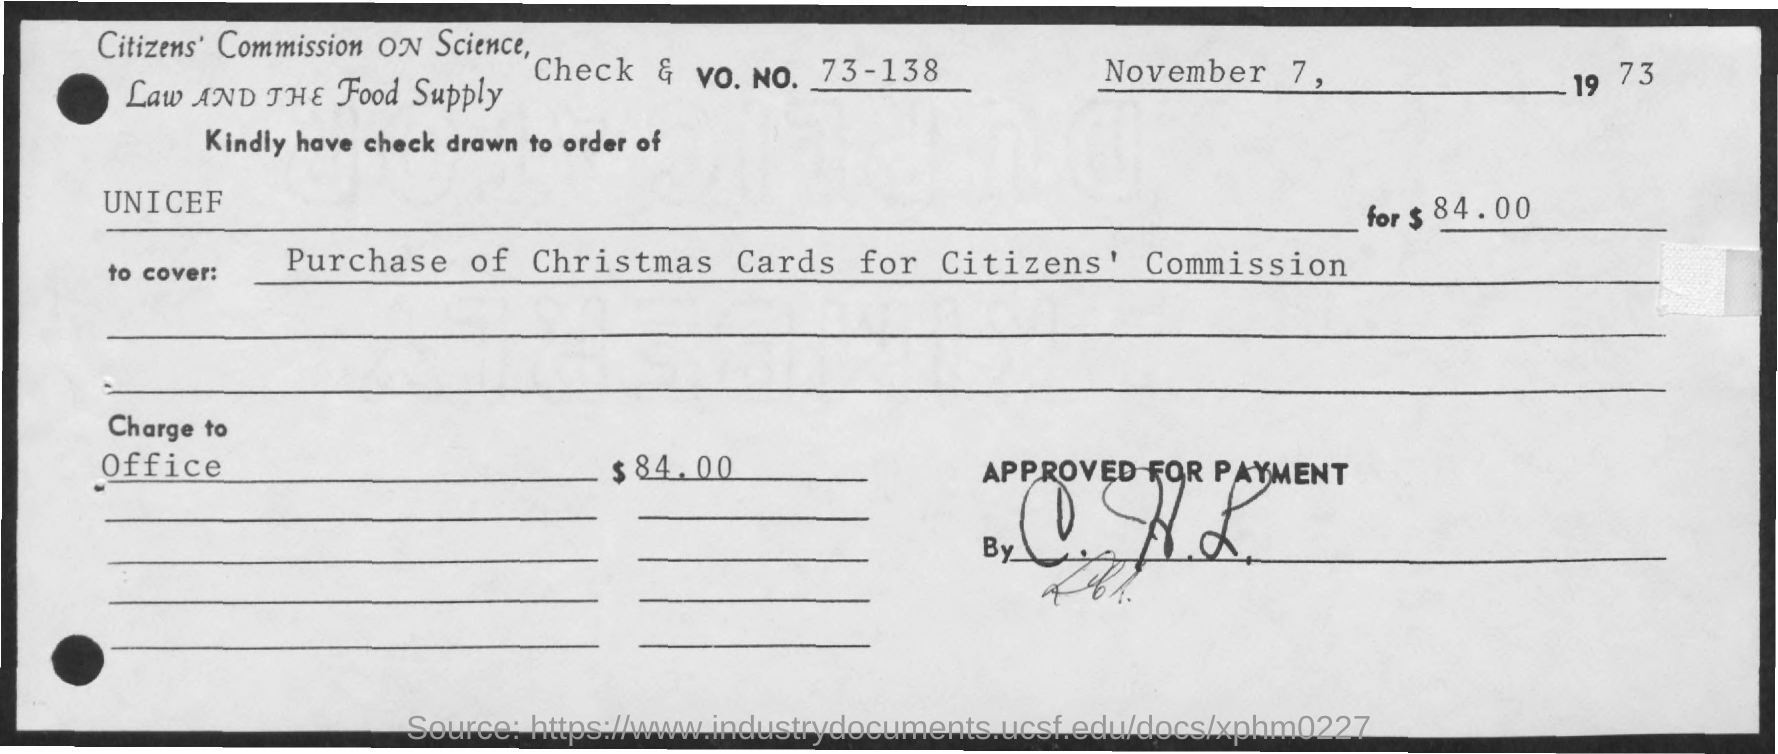What is the Vo. No. mentioned in the check?
Your response must be concise. 73 - 138. What is the check dated?
Your answer should be very brief. November 7, 1973. What is the amount of check given?
Make the answer very short. $84.00. In whose name, the check is payable?
Ensure brevity in your answer.  UNICEF. What charges are covered with the check given?
Keep it short and to the point. PURCHASE OF CHRISTMAS CARDS FOR CITIZEN'S COMMISSION. 